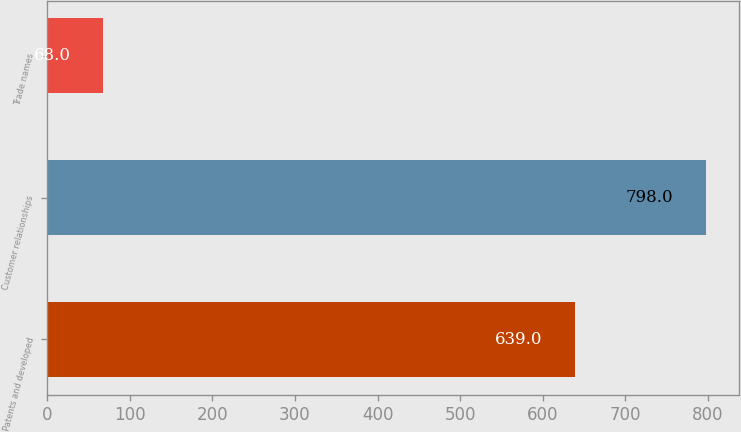<chart> <loc_0><loc_0><loc_500><loc_500><bar_chart><fcel>Patents and developed<fcel>Customer relationships<fcel>Trade names<nl><fcel>639<fcel>798<fcel>68<nl></chart> 